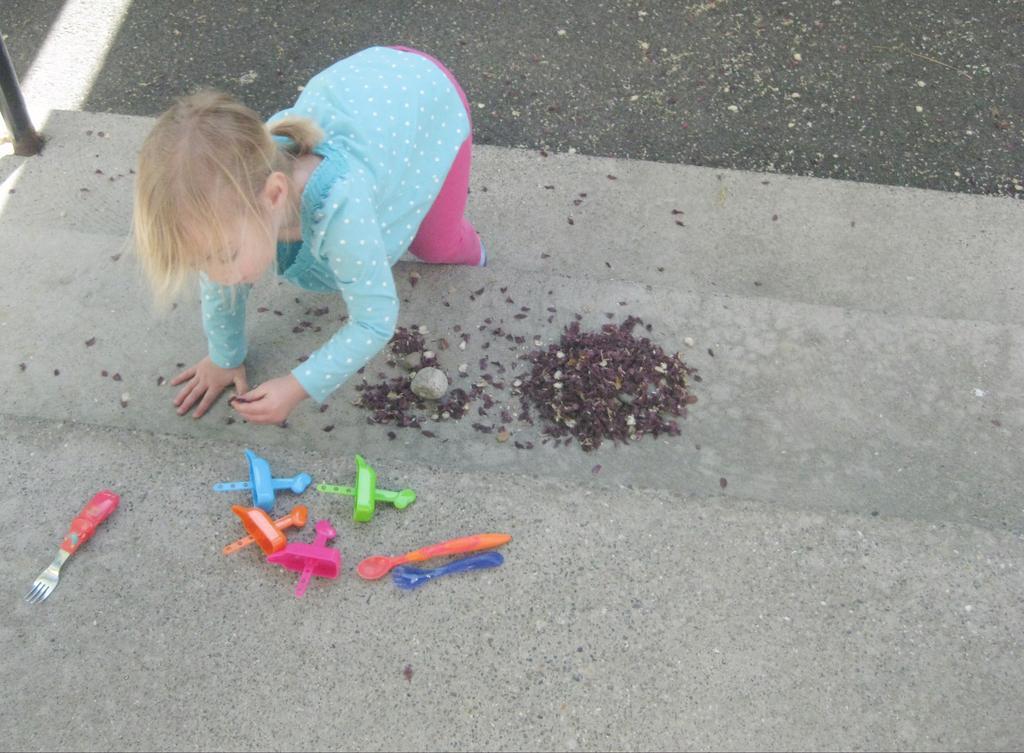How would you summarize this image in a sentence or two? In the image there is a girl on the steps and she is in bending position. On the steps there is a fork, few toys and some brown color items on the ground. In the top left corner of the image there is a pole. 